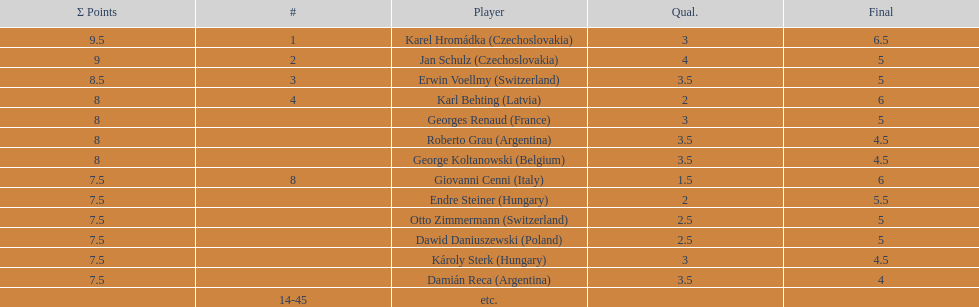How many countries had more than one player in the consolation cup? 4. 